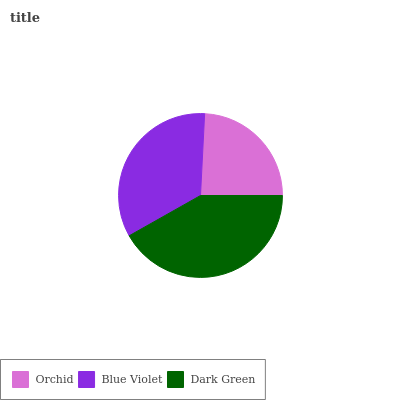Is Orchid the minimum?
Answer yes or no. Yes. Is Dark Green the maximum?
Answer yes or no. Yes. Is Blue Violet the minimum?
Answer yes or no. No. Is Blue Violet the maximum?
Answer yes or no. No. Is Blue Violet greater than Orchid?
Answer yes or no. Yes. Is Orchid less than Blue Violet?
Answer yes or no. Yes. Is Orchid greater than Blue Violet?
Answer yes or no. No. Is Blue Violet less than Orchid?
Answer yes or no. No. Is Blue Violet the high median?
Answer yes or no. Yes. Is Blue Violet the low median?
Answer yes or no. Yes. Is Dark Green the high median?
Answer yes or no. No. Is Dark Green the low median?
Answer yes or no. No. 